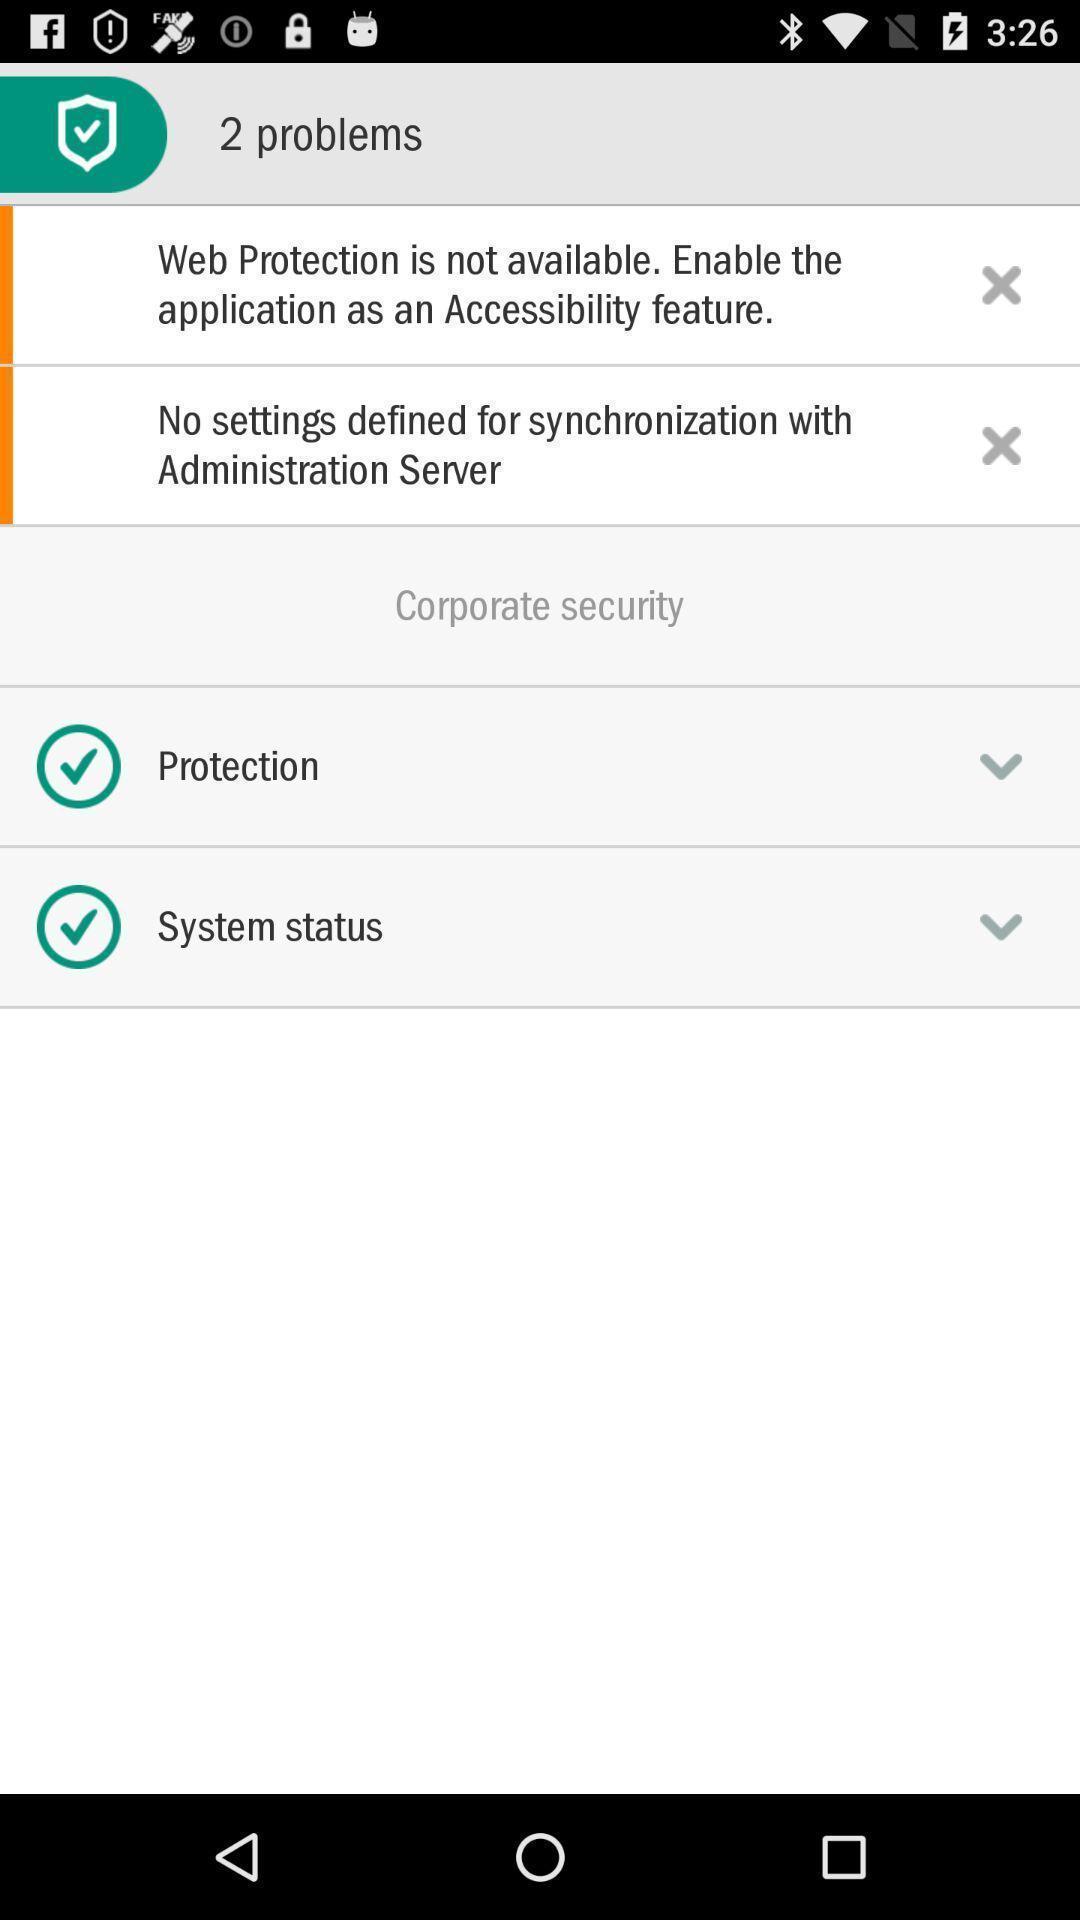Describe the content in this image. Screen shows multiple options. 